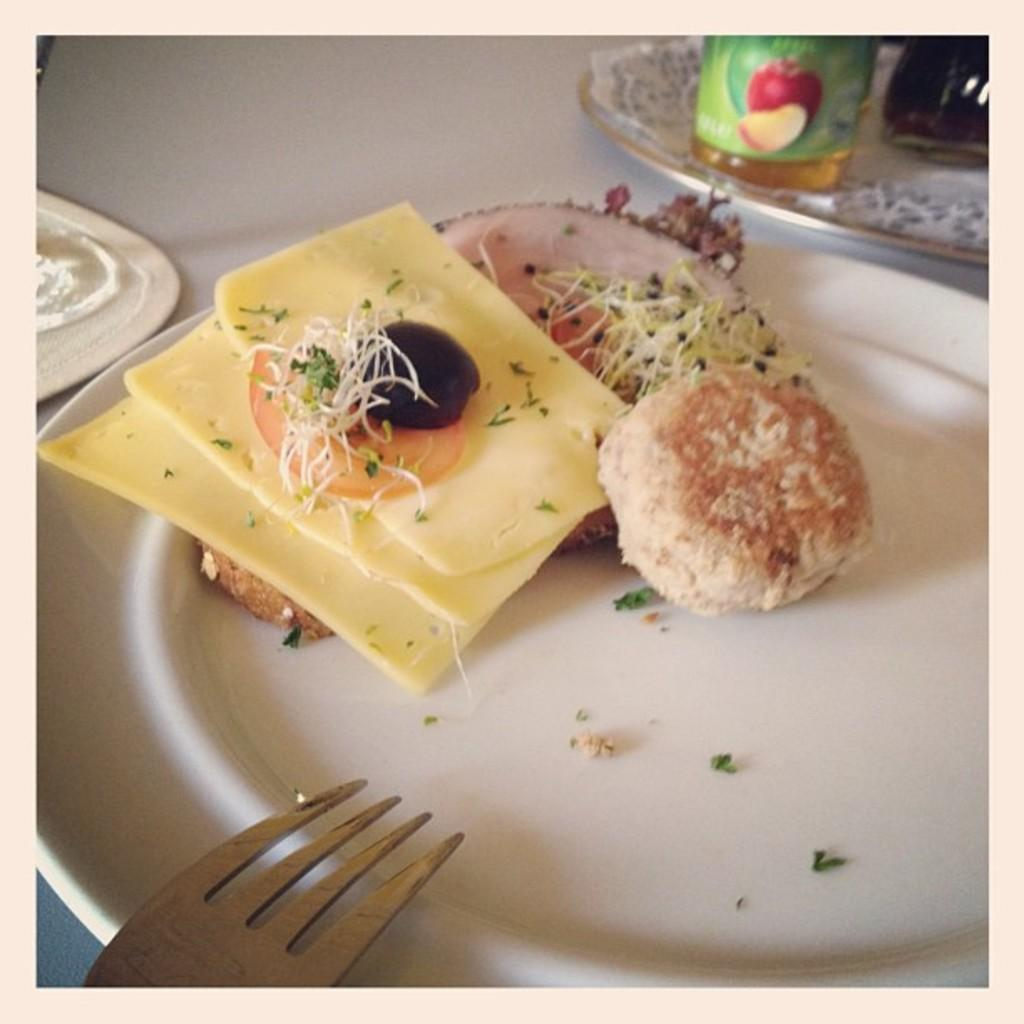What is on the plate that is visible in the image? There are snacks on the plate in the image. What else can be seen on the table besides the plate? There is a bottle on the table in the image. Can you describe the unspecified object in the left corner of the image? Unfortunately, the facts provided do not give enough information to describe the unspecified object in the left corner of the image. What type of system is being demonstrated in the image? There is no system being demonstrated in the image; it features a plate with snacks, a bottle, and an unspecified object in the left corner. What color is the neck of the person in the image? There is no person present in the image, so it is not possible to determine the color of their neck. 